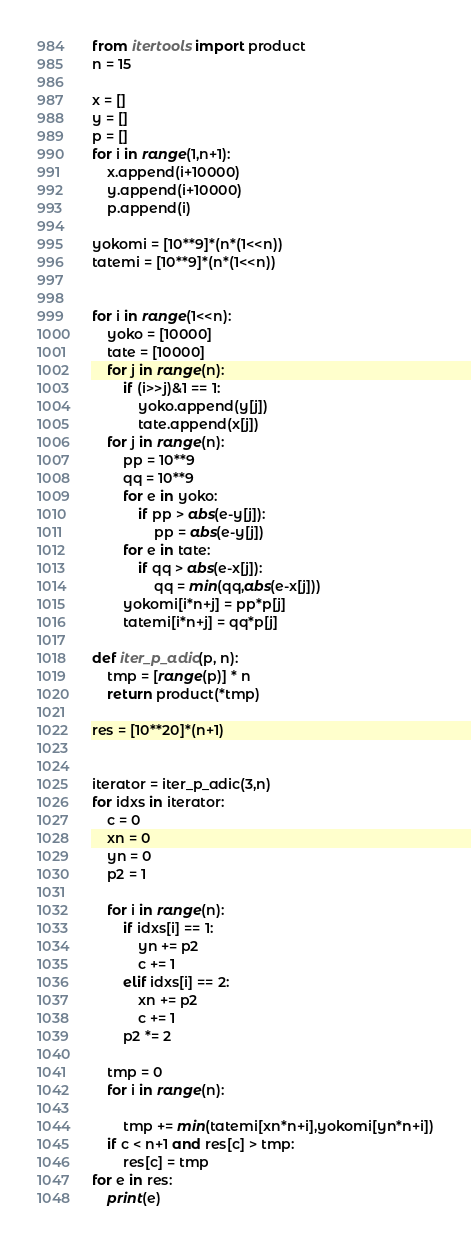<code> <loc_0><loc_0><loc_500><loc_500><_Python_>
from itertools import product
n = 15

x = []
y = []
p = []
for i in range(1,n+1):
    x.append(i+10000)
    y.append(i+10000)
    p.append(i)

yokomi = [10**9]*(n*(1<<n))
tatemi = [10**9]*(n*(1<<n))


for i in range(1<<n):
    yoko = [10000]
    tate = [10000]
    for j in range(n):
        if (i>>j)&1 == 1:
            yoko.append(y[j])
            tate.append(x[j])
    for j in range(n):
        pp = 10**9
        qq = 10**9
        for e in yoko:
            if pp > abs(e-y[j]):
                pp = abs(e-y[j])
        for e in tate:
            if qq > abs(e-x[j]):
                qq = min(qq,abs(e-x[j]))
        yokomi[i*n+j] = pp*p[j]
        tatemi[i*n+j] = qq*p[j]

def iter_p_adic(p, n):
    tmp = [range(p)] * n
    return product(*tmp)

res = [10**20]*(n+1)


iterator = iter_p_adic(3,n)
for idxs in iterator:
    c = 0
    xn = 0
    yn = 0
    p2 = 1

    for i in range(n):
        if idxs[i] == 1:
            yn += p2
            c += 1
        elif idxs[i] == 2:
            xn += p2
            c += 1
        p2 *= 2

    tmp = 0
    for i in range(n):

        tmp += min(tatemi[xn*n+i],yokomi[yn*n+i])
    if c < n+1 and res[c] > tmp:
        res[c] = tmp
for e in res:
    print(e)
</code> 